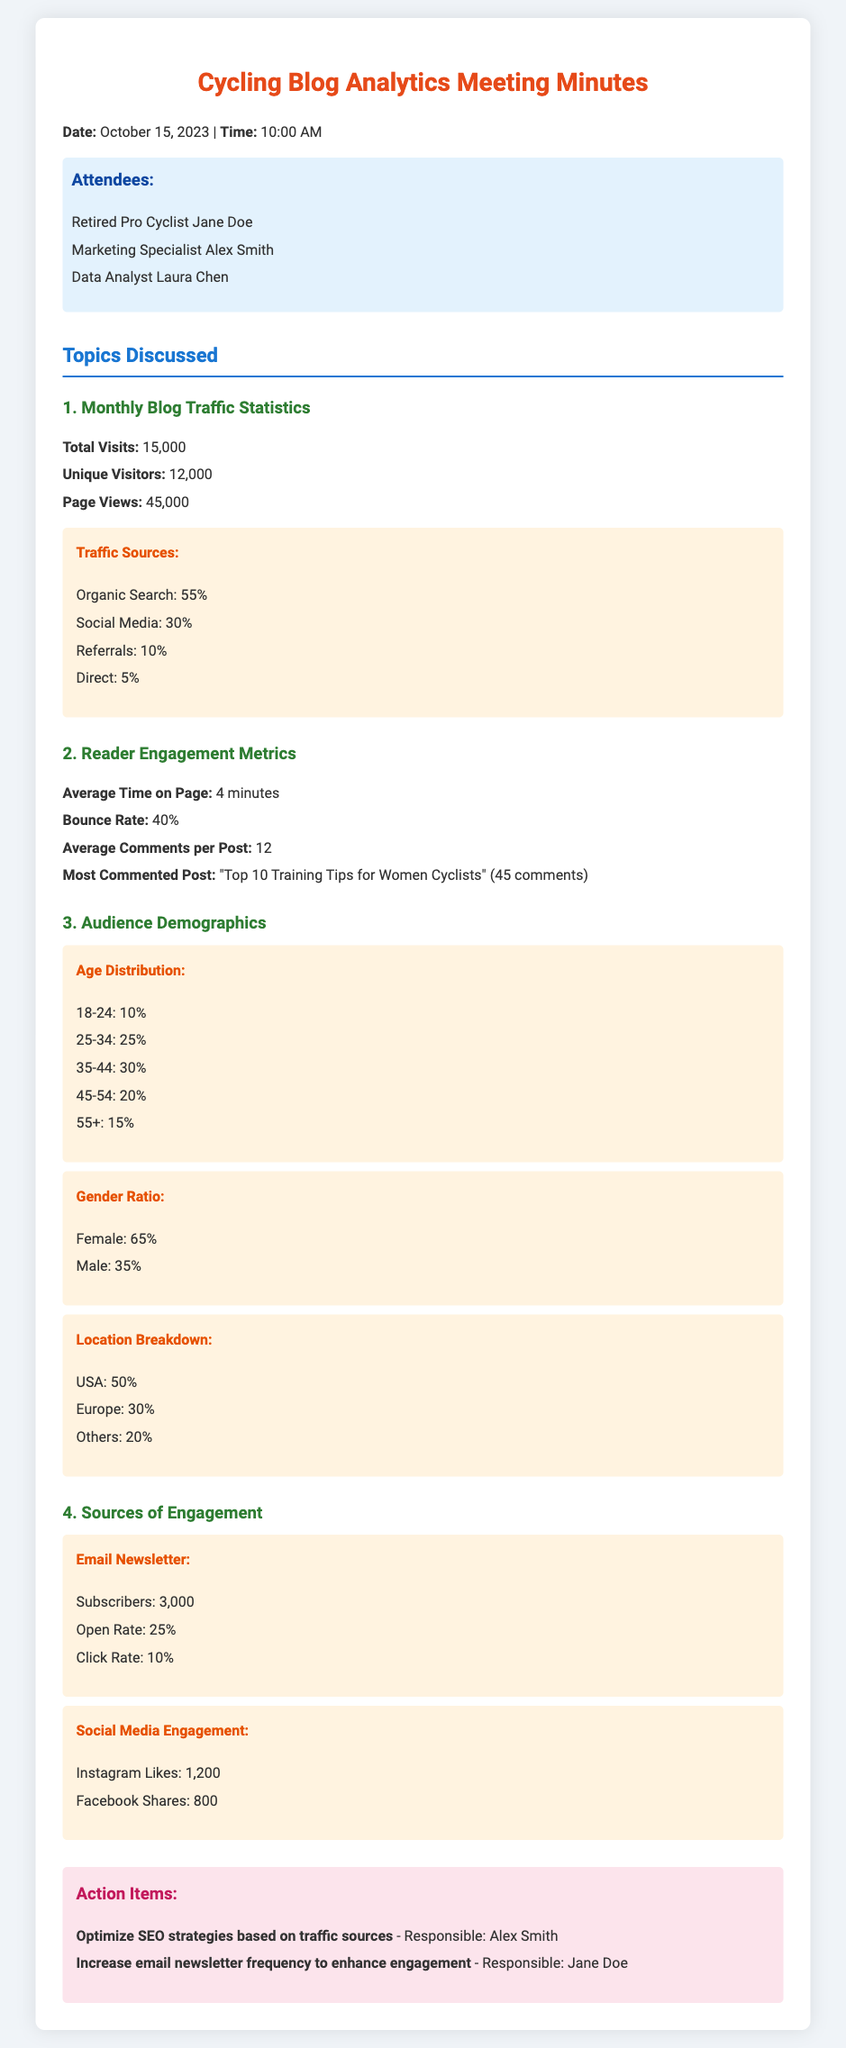What was the total number of visits to the blog? The total number of visits mentioned in the document is stated under "Monthly Blog Traffic Statistics."
Answer: 15,000 What is the bounce rate? The bounce rate is detailed in the "Reader Engagement Metrics" section, indicating how many visitors left the site after viewing only one page.
Answer: 40% How many subscribers does the email newsletter have? The number of subscribers is mentioned in the "Sources of Engagement" section, referring to newsletter subscribers.
Answer: 3,000 Which post received the most comments? The "Most Commented Post" is listed under "Reader Engagement Metrics," detailing the title and number of comments.
Answer: "Top 10 Training Tips for Women Cyclists" What percentage of blog visitors come from organic search? This percentage can be found in the "Traffic Sources" section, breaking down the traffic origins.
Answer: 55% What is the average time spent on the blog? The average time on page is mentioned in the "Reader Engagement Metrics," giving insight into how long visitors stay.
Answer: 4 minutes What percentage of the audience is female? The gender ratio is explored in the "Audience Demographics" section, specifically highlighting the female percentage.
Answer: 65% What action item involves email newsletters? This action item is listed under "Action Items" and refers to enhancing engagement through the newsletter.
Answer: Increase email newsletter frequency to enhance engagement What is the primary source of traffic to the blog? The primary source of traffic can be determined by reviewing the "Traffic Sources" section, which lists sources and their respective percentages.
Answer: Organic Search 